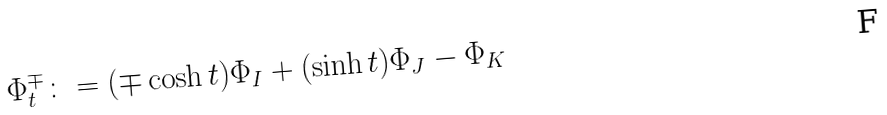<formula> <loc_0><loc_0><loc_500><loc_500>\Phi _ { t } ^ { \mp } \colon = ( \mp \cosh t ) \Phi _ { I } + ( \sinh t ) \Phi _ { J } - \Phi _ { K }</formula> 